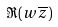<formula> <loc_0><loc_0><loc_500><loc_500>\Re ( w { \overline { z } } )</formula> 